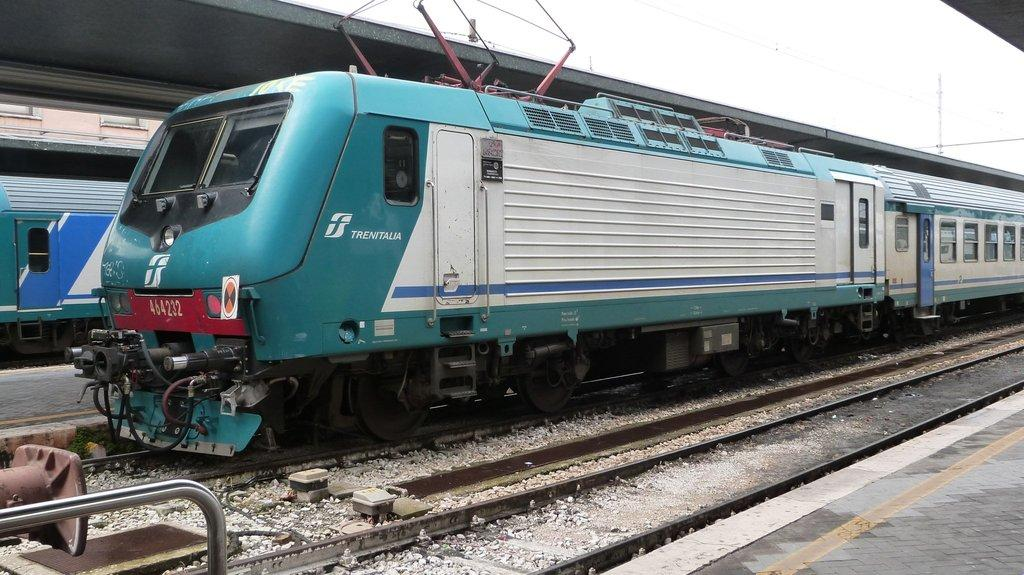Provide a one-sentence caption for the provided image. a train with the name of Trenitalia on the side. 